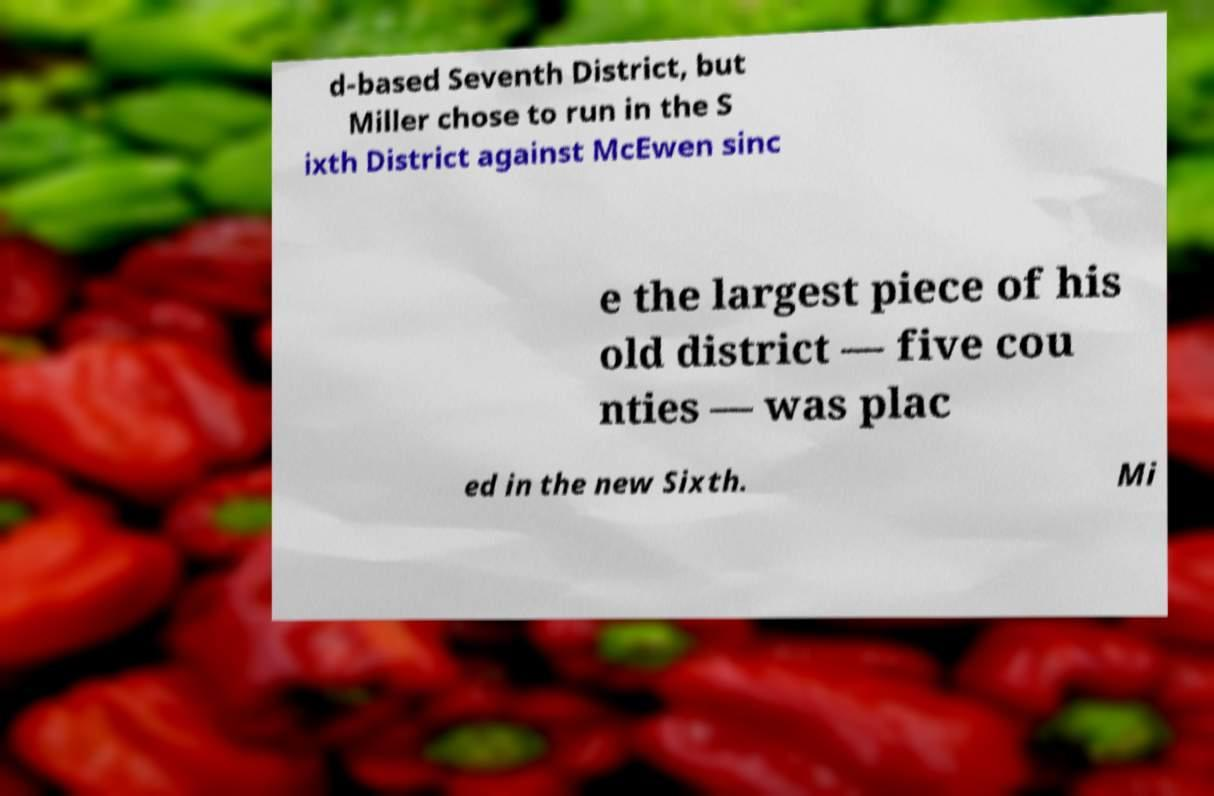I need the written content from this picture converted into text. Can you do that? d-based Seventh District, but Miller chose to run in the S ixth District against McEwen sinc e the largest piece of his old district — five cou nties — was plac ed in the new Sixth. Mi 